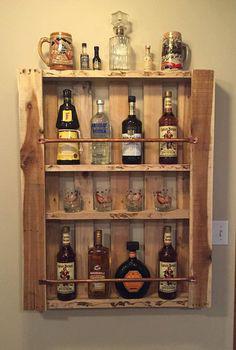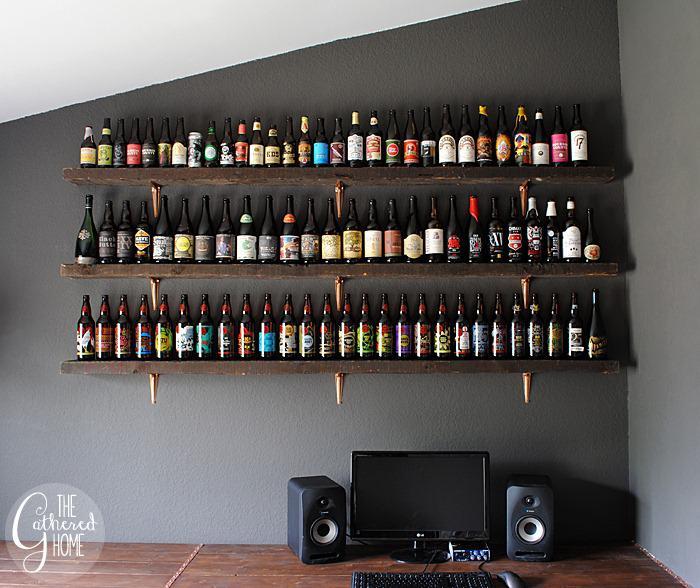The first image is the image on the left, the second image is the image on the right. Evaluate the accuracy of this statement regarding the images: "An image shows only one shelf with at least 13 bottles lined in a row.". Is it true? Answer yes or no. No. 